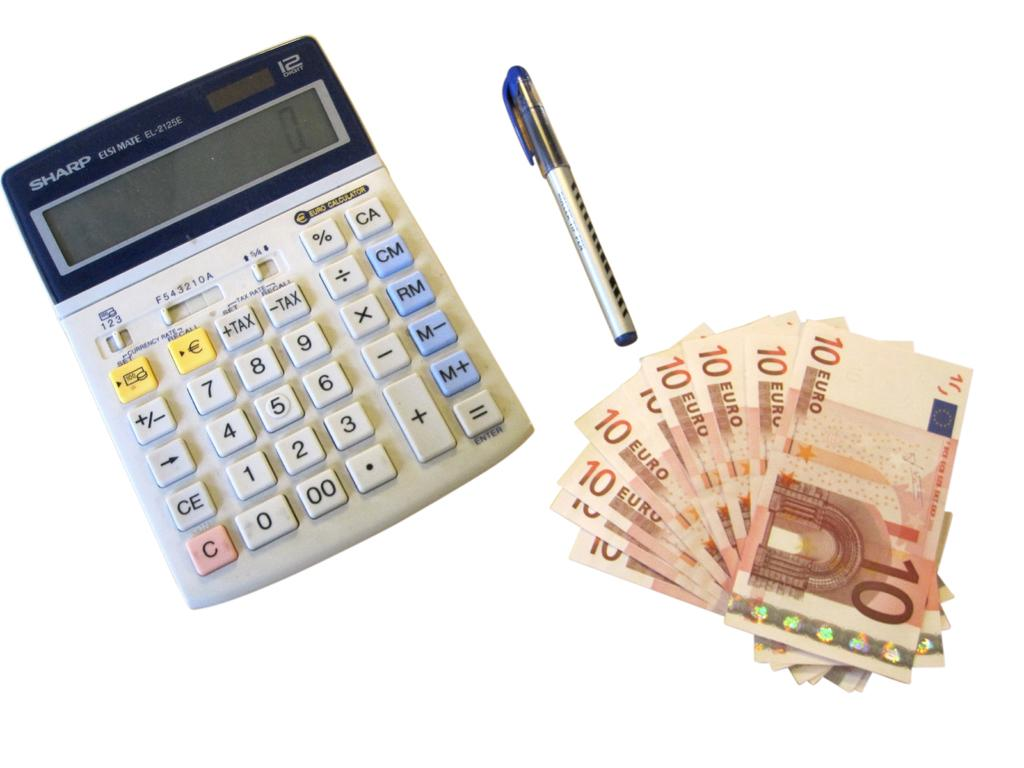<image>
Share a concise interpretation of the image provided. On the calculator the number 2 is to the right of the number 1. 